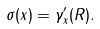<formula> <loc_0><loc_0><loc_500><loc_500>\sigma ( x ) = \gamma ^ { \prime } _ { x } ( R ) .</formula> 